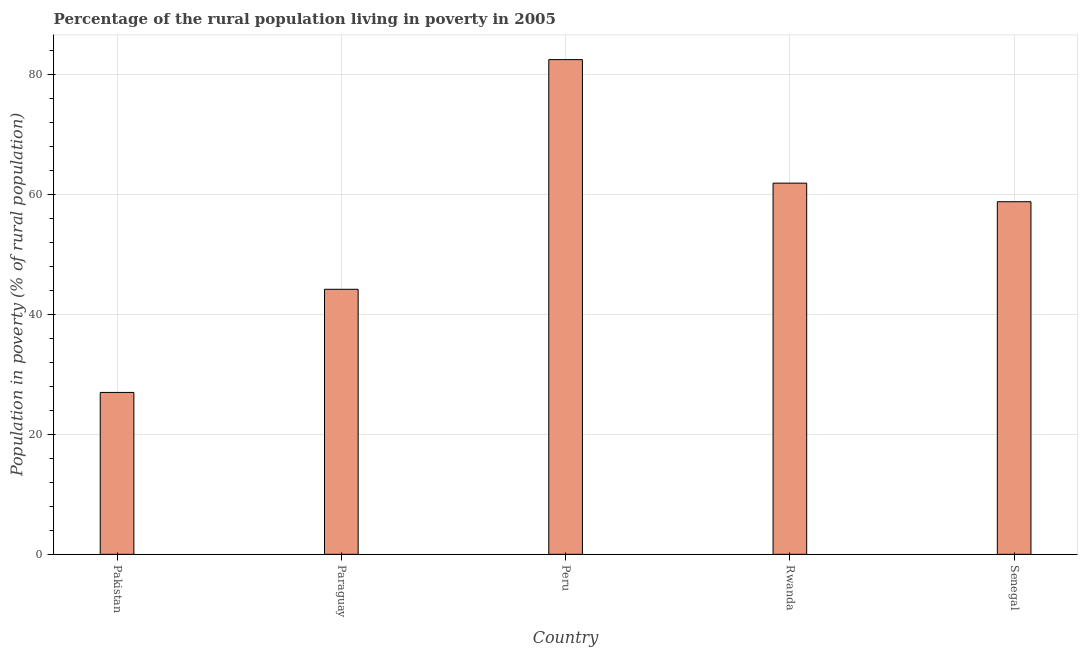What is the title of the graph?
Offer a terse response. Percentage of the rural population living in poverty in 2005. What is the label or title of the Y-axis?
Ensure brevity in your answer.  Population in poverty (% of rural population). What is the percentage of rural population living below poverty line in Paraguay?
Make the answer very short. 44.2. Across all countries, what is the maximum percentage of rural population living below poverty line?
Provide a succinct answer. 82.5. In which country was the percentage of rural population living below poverty line minimum?
Ensure brevity in your answer.  Pakistan. What is the sum of the percentage of rural population living below poverty line?
Keep it short and to the point. 274.4. What is the difference between the percentage of rural population living below poverty line in Paraguay and Senegal?
Offer a very short reply. -14.6. What is the average percentage of rural population living below poverty line per country?
Provide a short and direct response. 54.88. What is the median percentage of rural population living below poverty line?
Ensure brevity in your answer.  58.8. In how many countries, is the percentage of rural population living below poverty line greater than 44 %?
Provide a succinct answer. 4. What is the ratio of the percentage of rural population living below poverty line in Pakistan to that in Paraguay?
Your answer should be very brief. 0.61. What is the difference between the highest and the second highest percentage of rural population living below poverty line?
Make the answer very short. 20.6. What is the difference between the highest and the lowest percentage of rural population living below poverty line?
Your answer should be compact. 55.5. In how many countries, is the percentage of rural population living below poverty line greater than the average percentage of rural population living below poverty line taken over all countries?
Your answer should be compact. 3. How many bars are there?
Ensure brevity in your answer.  5. How many countries are there in the graph?
Provide a succinct answer. 5. What is the difference between two consecutive major ticks on the Y-axis?
Your response must be concise. 20. Are the values on the major ticks of Y-axis written in scientific E-notation?
Offer a terse response. No. What is the Population in poverty (% of rural population) in Paraguay?
Your answer should be compact. 44.2. What is the Population in poverty (% of rural population) in Peru?
Provide a succinct answer. 82.5. What is the Population in poverty (% of rural population) in Rwanda?
Provide a short and direct response. 61.9. What is the Population in poverty (% of rural population) of Senegal?
Keep it short and to the point. 58.8. What is the difference between the Population in poverty (% of rural population) in Pakistan and Paraguay?
Your answer should be compact. -17.2. What is the difference between the Population in poverty (% of rural population) in Pakistan and Peru?
Ensure brevity in your answer.  -55.5. What is the difference between the Population in poverty (% of rural population) in Pakistan and Rwanda?
Offer a very short reply. -34.9. What is the difference between the Population in poverty (% of rural population) in Pakistan and Senegal?
Provide a short and direct response. -31.8. What is the difference between the Population in poverty (% of rural population) in Paraguay and Peru?
Offer a terse response. -38.3. What is the difference between the Population in poverty (% of rural population) in Paraguay and Rwanda?
Your answer should be very brief. -17.7. What is the difference between the Population in poverty (% of rural population) in Paraguay and Senegal?
Ensure brevity in your answer.  -14.6. What is the difference between the Population in poverty (% of rural population) in Peru and Rwanda?
Your response must be concise. 20.6. What is the difference between the Population in poverty (% of rural population) in Peru and Senegal?
Provide a short and direct response. 23.7. What is the ratio of the Population in poverty (% of rural population) in Pakistan to that in Paraguay?
Make the answer very short. 0.61. What is the ratio of the Population in poverty (% of rural population) in Pakistan to that in Peru?
Keep it short and to the point. 0.33. What is the ratio of the Population in poverty (% of rural population) in Pakistan to that in Rwanda?
Ensure brevity in your answer.  0.44. What is the ratio of the Population in poverty (% of rural population) in Pakistan to that in Senegal?
Ensure brevity in your answer.  0.46. What is the ratio of the Population in poverty (% of rural population) in Paraguay to that in Peru?
Offer a terse response. 0.54. What is the ratio of the Population in poverty (% of rural population) in Paraguay to that in Rwanda?
Your response must be concise. 0.71. What is the ratio of the Population in poverty (% of rural population) in Paraguay to that in Senegal?
Ensure brevity in your answer.  0.75. What is the ratio of the Population in poverty (% of rural population) in Peru to that in Rwanda?
Your answer should be compact. 1.33. What is the ratio of the Population in poverty (% of rural population) in Peru to that in Senegal?
Ensure brevity in your answer.  1.4. What is the ratio of the Population in poverty (% of rural population) in Rwanda to that in Senegal?
Keep it short and to the point. 1.05. 